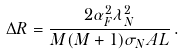<formula> <loc_0><loc_0><loc_500><loc_500>\Delta R = \frac { 2 \alpha _ { F } ^ { 2 } \lambda _ { N } ^ { 2 } } { M ( M + 1 ) \sigma _ { N } A L } \, .</formula> 